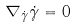Convert formula to latex. <formula><loc_0><loc_0><loc_500><loc_500>\nabla _ { \dot { \gamma } } { \dot { \gamma } } = 0</formula> 